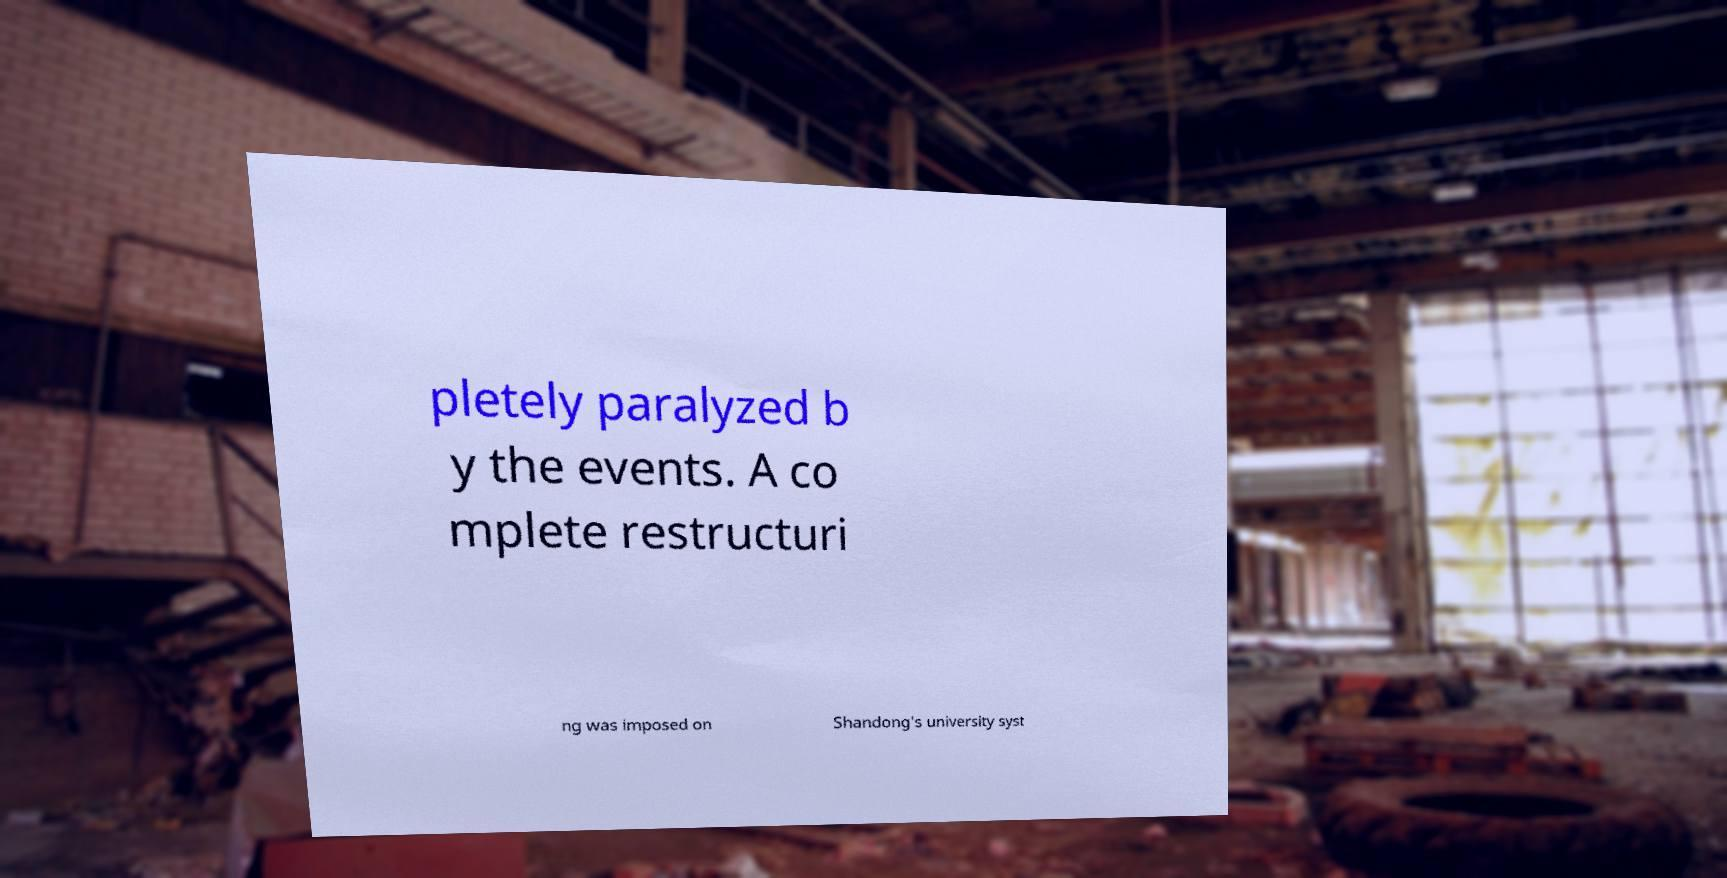Could you extract and type out the text from this image? pletely paralyzed b y the events. A co mplete restructuri ng was imposed on Shandong's university syst 